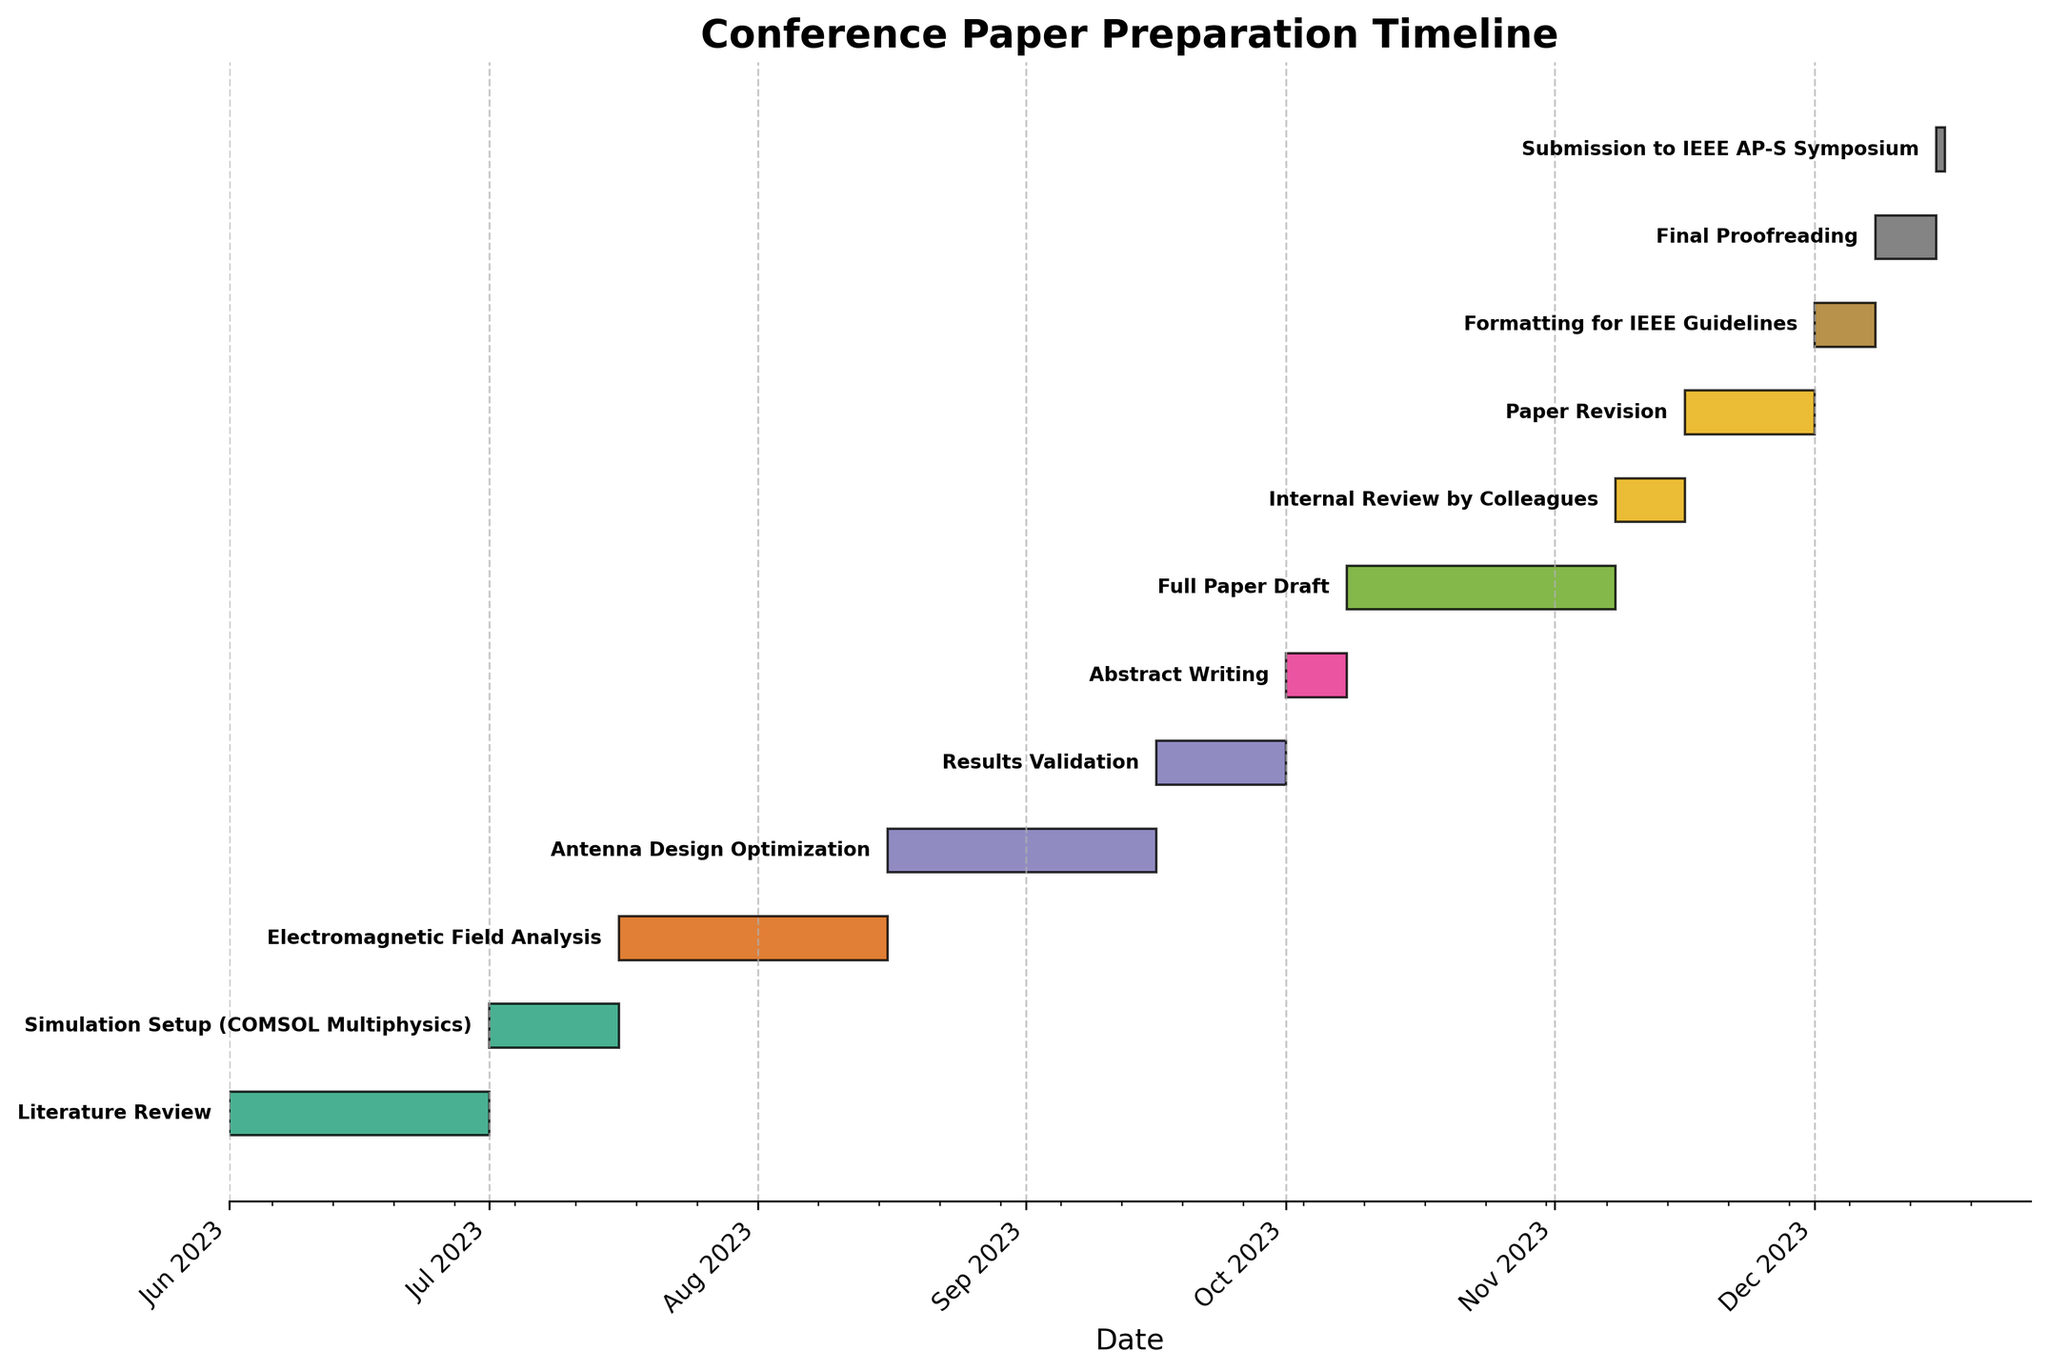When are the dates for the "Literature Review" task? The "Literature Review" task spans from June 1, 2023, to June 30, 2023. This can be determined by examining the labels on the timeline and the span of the colored bar corresponding to "Literature Review."
Answer: June 1, 2023 - June 30, 2023 What task occurs immediately after "Simulation Setup (COMSOL Multiphysics)"? "Electromagnetic Field Analysis" occurs immediately after "Simulation Setup (COMSOL Multiphysics)." This can be seen by noting the end date of "Simulation Setup" on July 15, 2023, and the start date of "Electromagnetic Field Analysis" on July 16, 2023.
Answer: Electromagnetic Field Analysis How long is the "Full Paper Draft" task in days? The "Full Paper Draft" task starts on October 8, 2023, and ends on November 7, 2023. The duration is calculated as the difference between these dates plus one day: (November 7 - October 8) + 1 = 31 days.
Answer: 31 days What tasks are scheduled between September 1, 2023, and September 30, 2023? "Antenna Design Optimization" and "Results Validation" are scheduled between these dates. "Antenna Design Optimization" covers the period from August 16 to September 15, and "Results Validation" covers from September 16 to September 30.
Answer: Antenna Design Optimization, Results Validation Which task has the shortest duration? The "Submission to IEEE AP-S Symposium" task has the shortest duration since it only occurs on a single day: December 15, 2023.
Answer: Submission to IEEE AP-S Symposium Is the "Paper Revision" task longer or shorter than the "Internal Review by Colleagues" task? The "Paper Revision" task is longer. It covers from November 16 to November 30 (15 days), while "Internal Review by Colleagues" covers from November 8 to November 15 (8 days).
Answer: Longer How many tasks have a duration of less than 10 days? Three tasks have a duration of less than 10 days: "Abstract Writing" (7 days), "Formatting for IEEE Guidelines" (7 days), and "Final Proofreading" (7 days).
Answer: 3 Before which task does the "Results Validation" task end? The "Results Validation" task ends on September 30, 2023, which is before the "Abstract Writing" task that starts on October 1, 2023.
Answer: Abstract Writing 